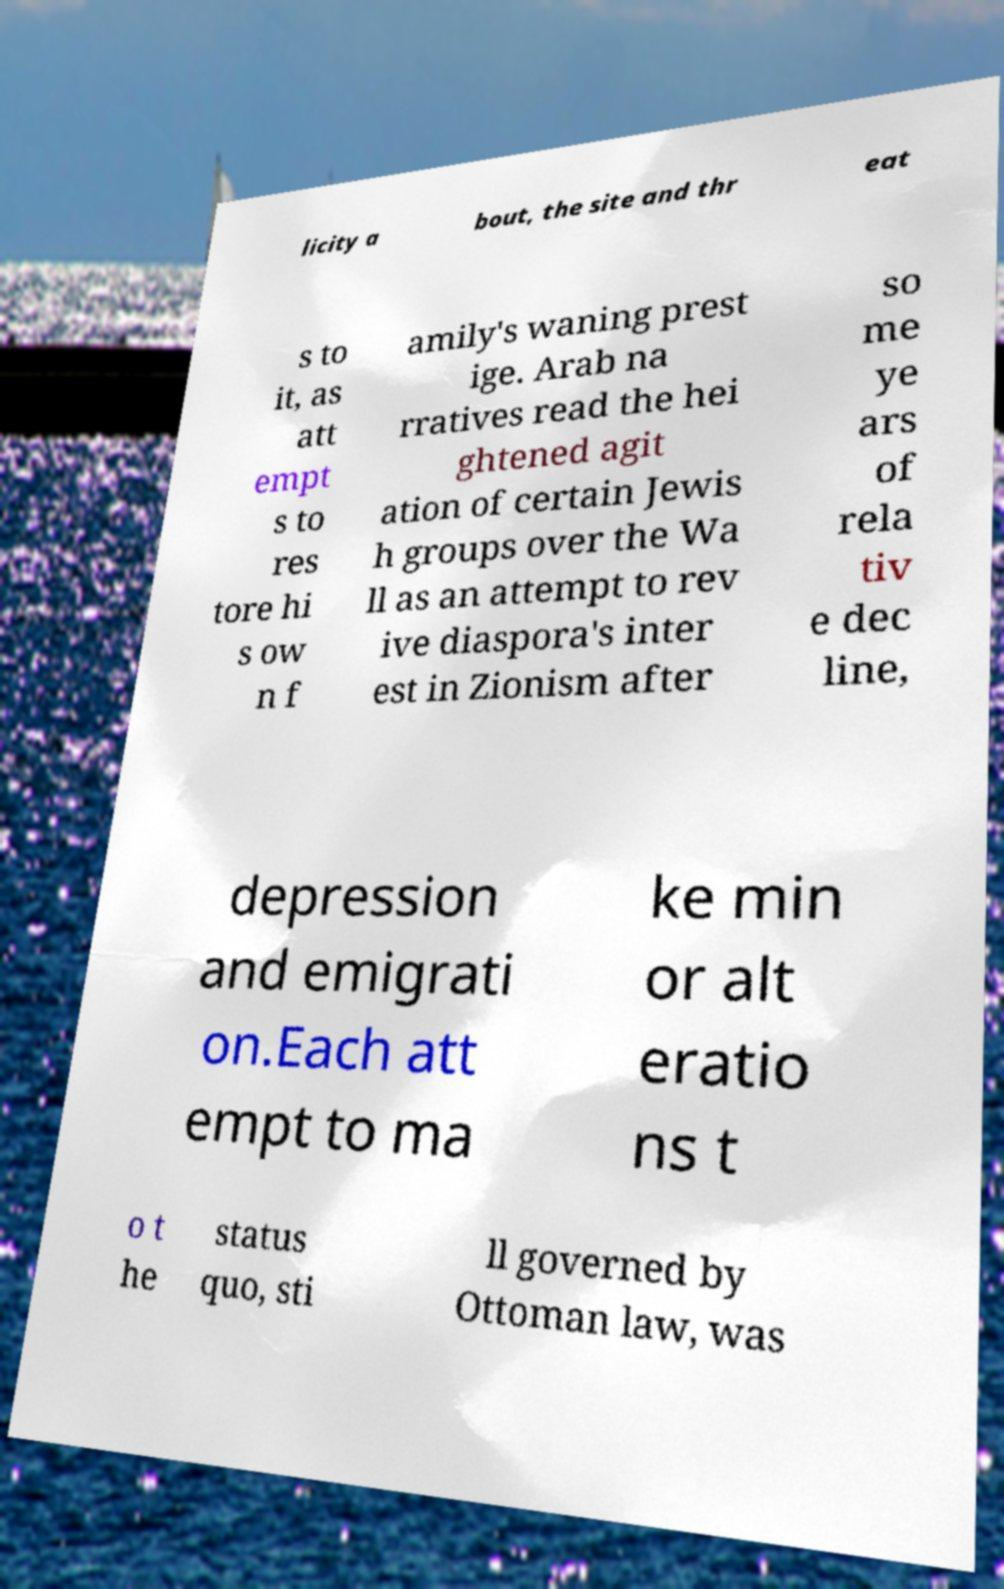For documentation purposes, I need the text within this image transcribed. Could you provide that? licity a bout, the site and thr eat s to it, as att empt s to res tore hi s ow n f amily's waning prest ige. Arab na rratives read the hei ghtened agit ation of certain Jewis h groups over the Wa ll as an attempt to rev ive diaspora's inter est in Zionism after so me ye ars of rela tiv e dec line, depression and emigrati on.Each att empt to ma ke min or alt eratio ns t o t he status quo, sti ll governed by Ottoman law, was 